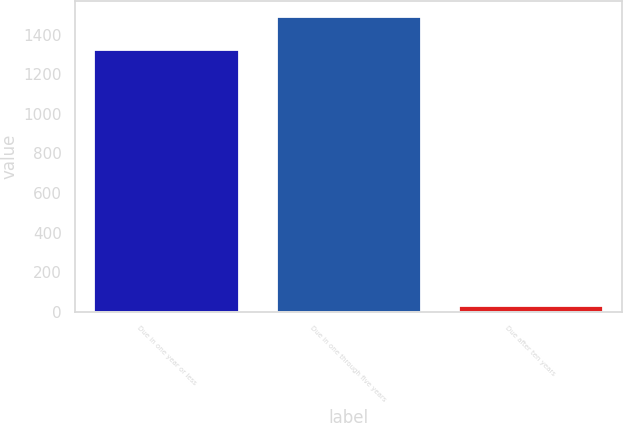Convert chart. <chart><loc_0><loc_0><loc_500><loc_500><bar_chart><fcel>Due in one year or less<fcel>Due in one through five years<fcel>Due after ten years<nl><fcel>1325.7<fcel>1493.4<fcel>36.9<nl></chart> 